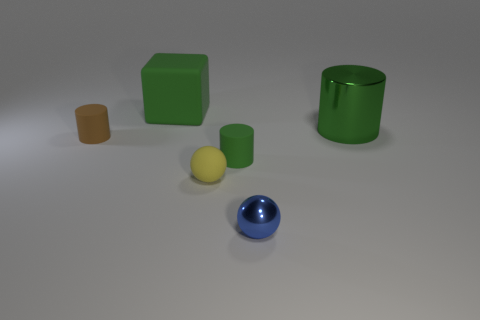Subtract all big green shiny cylinders. How many cylinders are left? 2 Add 2 tiny brown matte objects. How many objects exist? 8 Subtract all blue balls. How many balls are left? 1 Subtract 0 cyan blocks. How many objects are left? 6 Subtract all spheres. How many objects are left? 4 Subtract 2 cylinders. How many cylinders are left? 1 Subtract all purple balls. Subtract all brown blocks. How many balls are left? 2 Subtract all yellow cubes. How many blue spheres are left? 1 Subtract all yellow metal cylinders. Subtract all matte spheres. How many objects are left? 5 Add 1 cubes. How many cubes are left? 2 